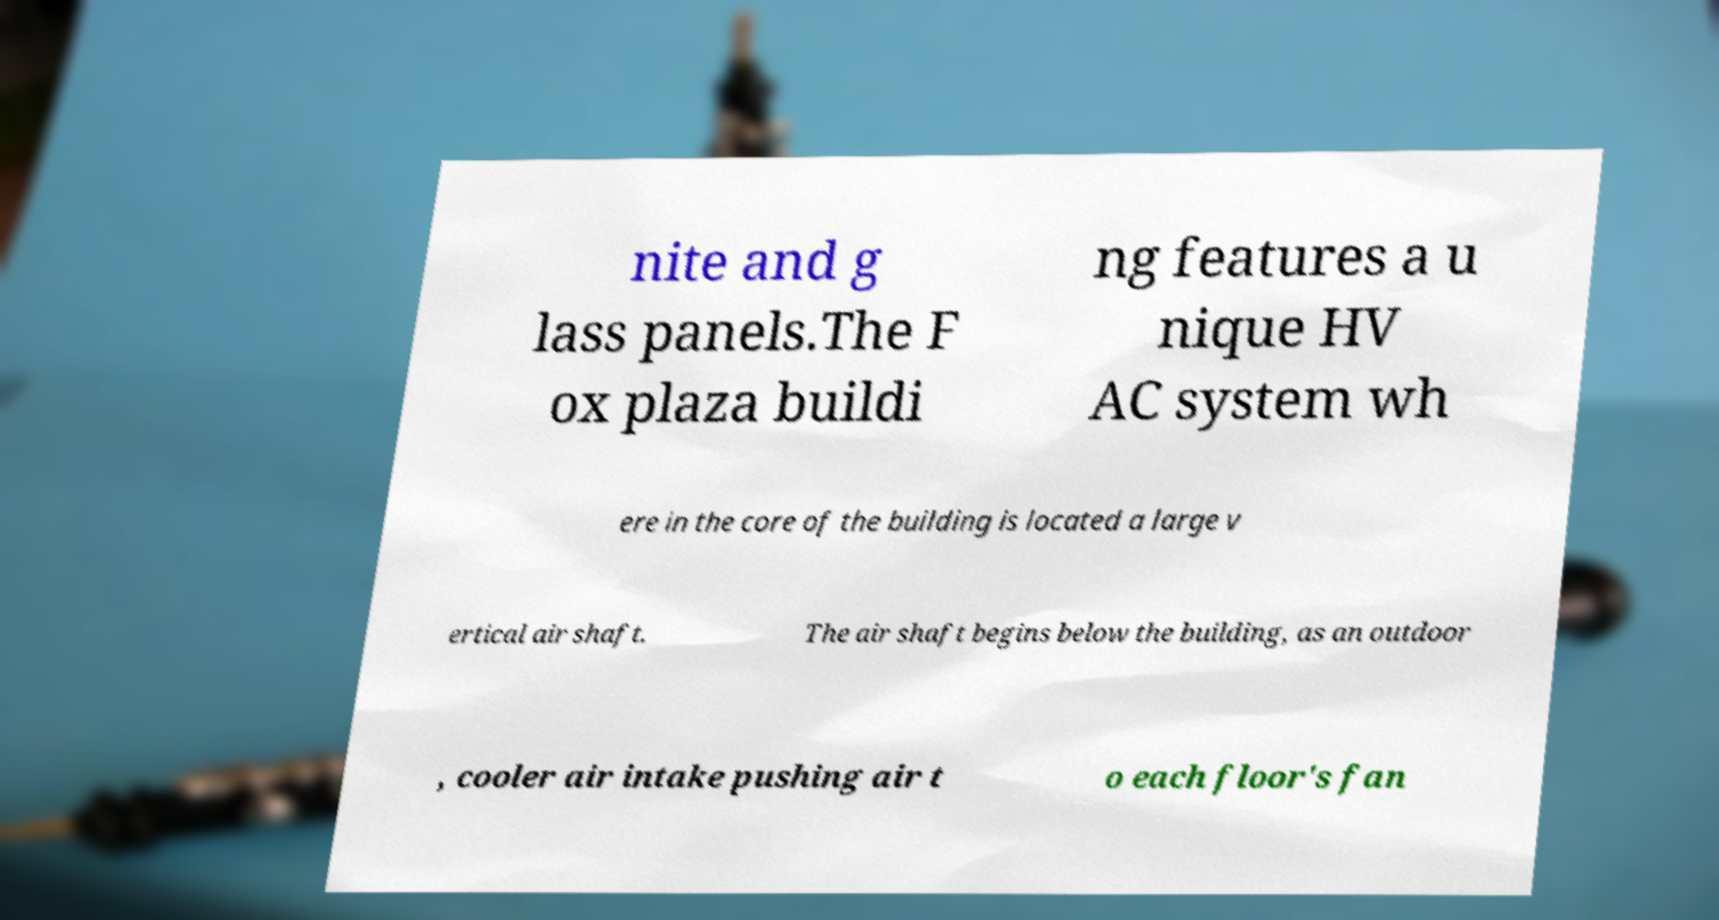What messages or text are displayed in this image? I need them in a readable, typed format. nite and g lass panels.The F ox plaza buildi ng features a u nique HV AC system wh ere in the core of the building is located a large v ertical air shaft. The air shaft begins below the building, as an outdoor , cooler air intake pushing air t o each floor's fan 